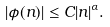Convert formula to latex. <formula><loc_0><loc_0><loc_500><loc_500>| \phi ( n ) | \leq C | n | ^ { \alpha } .</formula> 